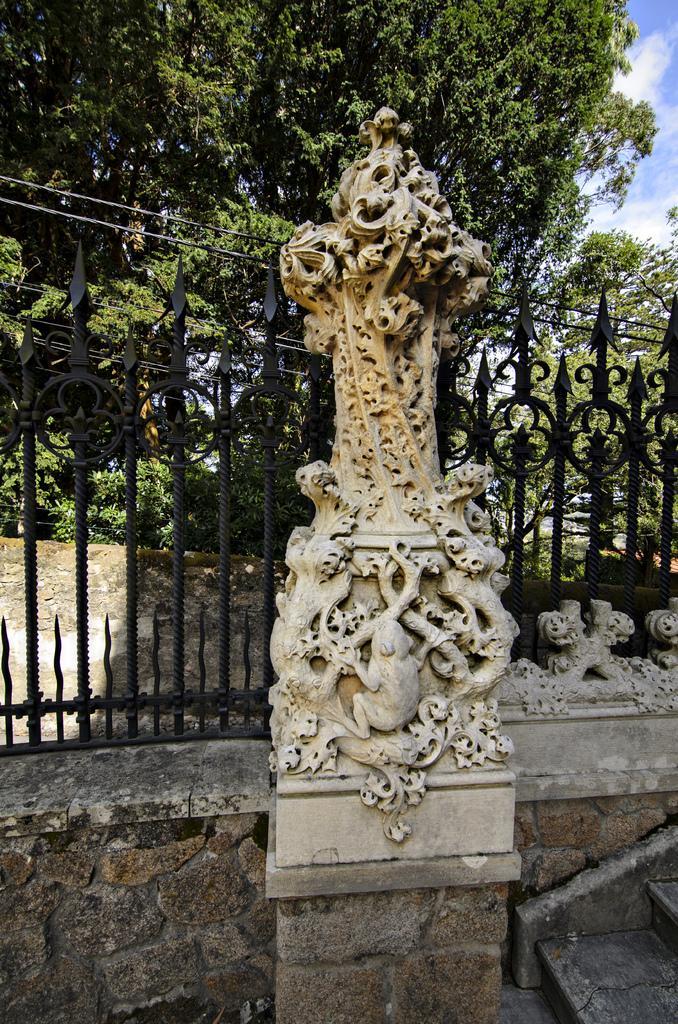In one or two sentences, can you explain what this image depicts? In this image we can see many trees. There is a fence in the image. There is a staircase at the bottom right most of the image. There is a sculpture in the image. We can see the clouds in the sky at the top right most of the image. 